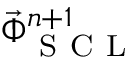<formula> <loc_0><loc_0><loc_500><loc_500>\vec { \Phi } _ { S C L } ^ { n + 1 }</formula> 